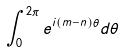<formula> <loc_0><loc_0><loc_500><loc_500>\int _ { 0 } ^ { 2 \pi } e ^ { i ( m - n ) \theta } d \theta</formula> 